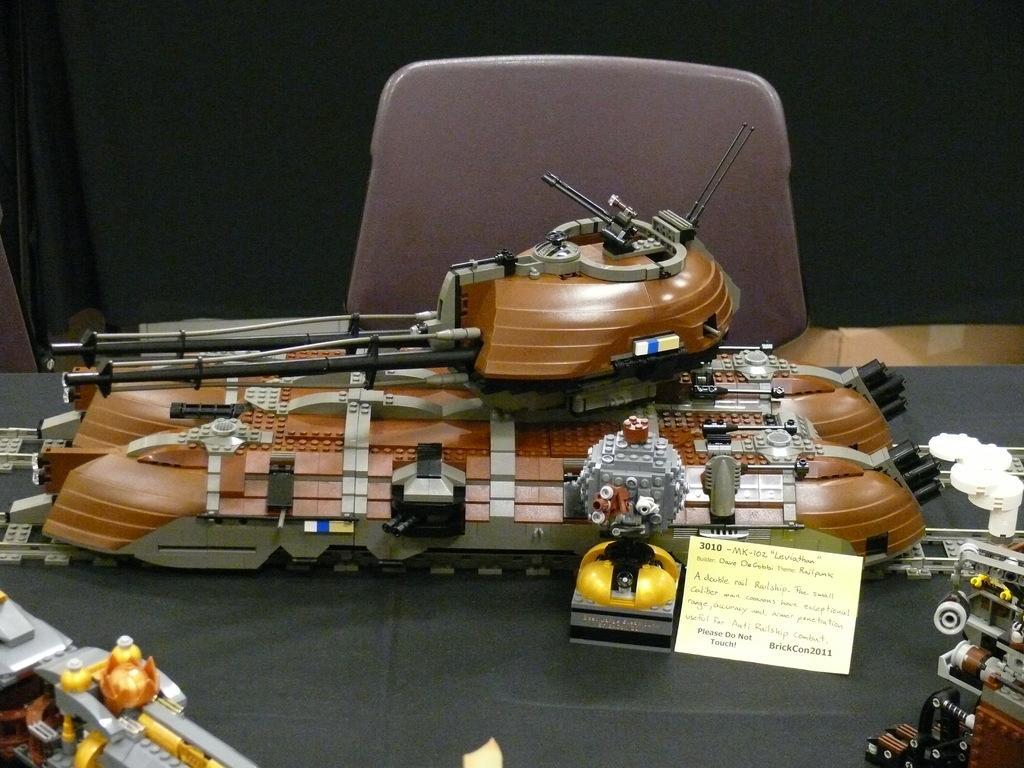In one or two sentences, can you explain what this image depicts? In this image we can see few vehicle models on the table. There is a chair in the image. There is a curtain in the image. 